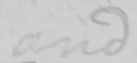What text is written in this handwritten line? and 